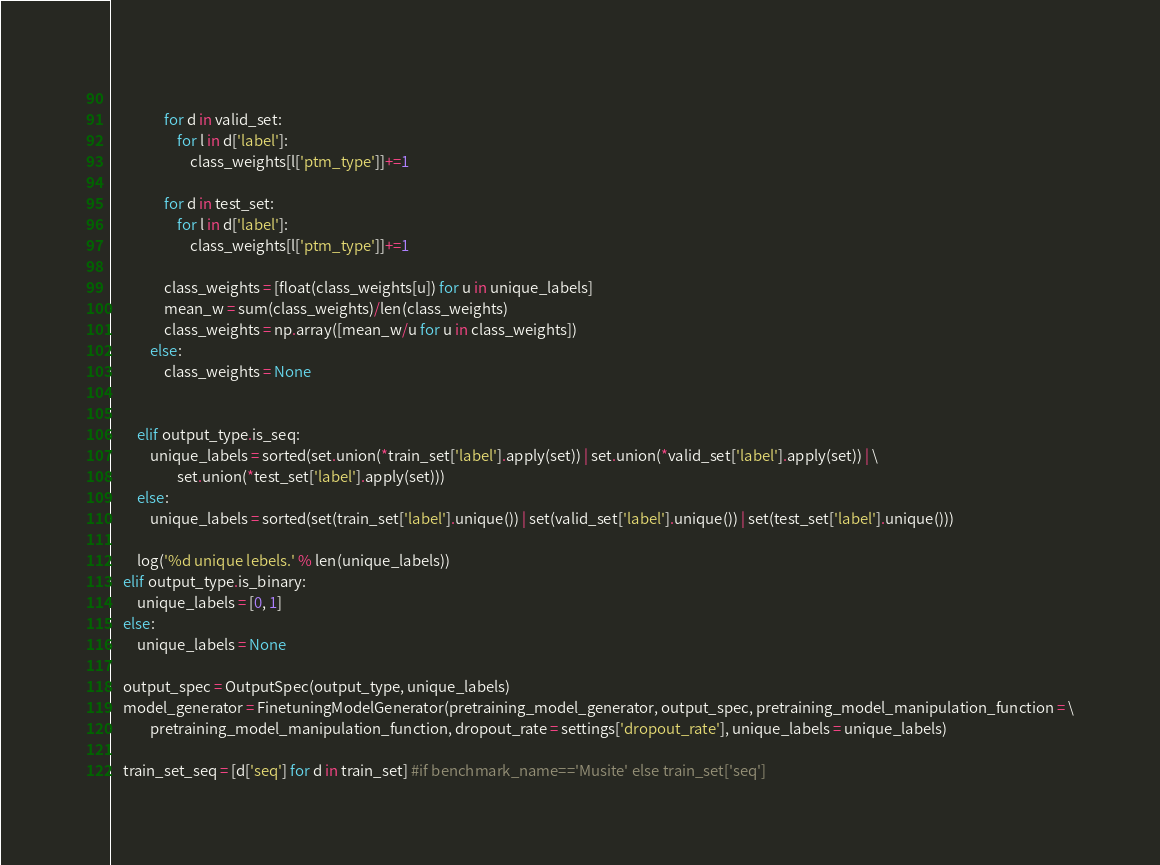Convert code to text. <code><loc_0><loc_0><loc_500><loc_500><_Python_>                
                for d in valid_set:
                    for l in d['label']:
                        class_weights[l['ptm_type']]+=1 
                
                for d in test_set:
                    for l in d['label']:
                        class_weights[l['ptm_type']]+=1 
                
                class_weights = [float(class_weights[u]) for u in unique_labels]
                mean_w = sum(class_weights)/len(class_weights)
                class_weights = np.array([mean_w/u for u in class_weights])
            else:
                class_weights = None


        elif output_type.is_seq:
            unique_labels = sorted(set.union(*train_set['label'].apply(set)) | set.union(*valid_set['label'].apply(set)) | \
                    set.union(*test_set['label'].apply(set)))
        else:
            unique_labels = sorted(set(train_set['label'].unique()) | set(valid_set['label'].unique()) | set(test_set['label'].unique()))
            
        log('%d unique lebels.' % len(unique_labels))
    elif output_type.is_binary:
        unique_labels = [0, 1]
    else:
        unique_labels = None
        
    output_spec = OutputSpec(output_type, unique_labels)
    model_generator = FinetuningModelGenerator(pretraining_model_generator, output_spec, pretraining_model_manipulation_function = \
            pretraining_model_manipulation_function, dropout_rate = settings['dropout_rate'], unique_labels = unique_labels)

    train_set_seq = [d['seq'] for d in train_set] #if benchmark_name=='Musite' else train_set['seq']</code> 